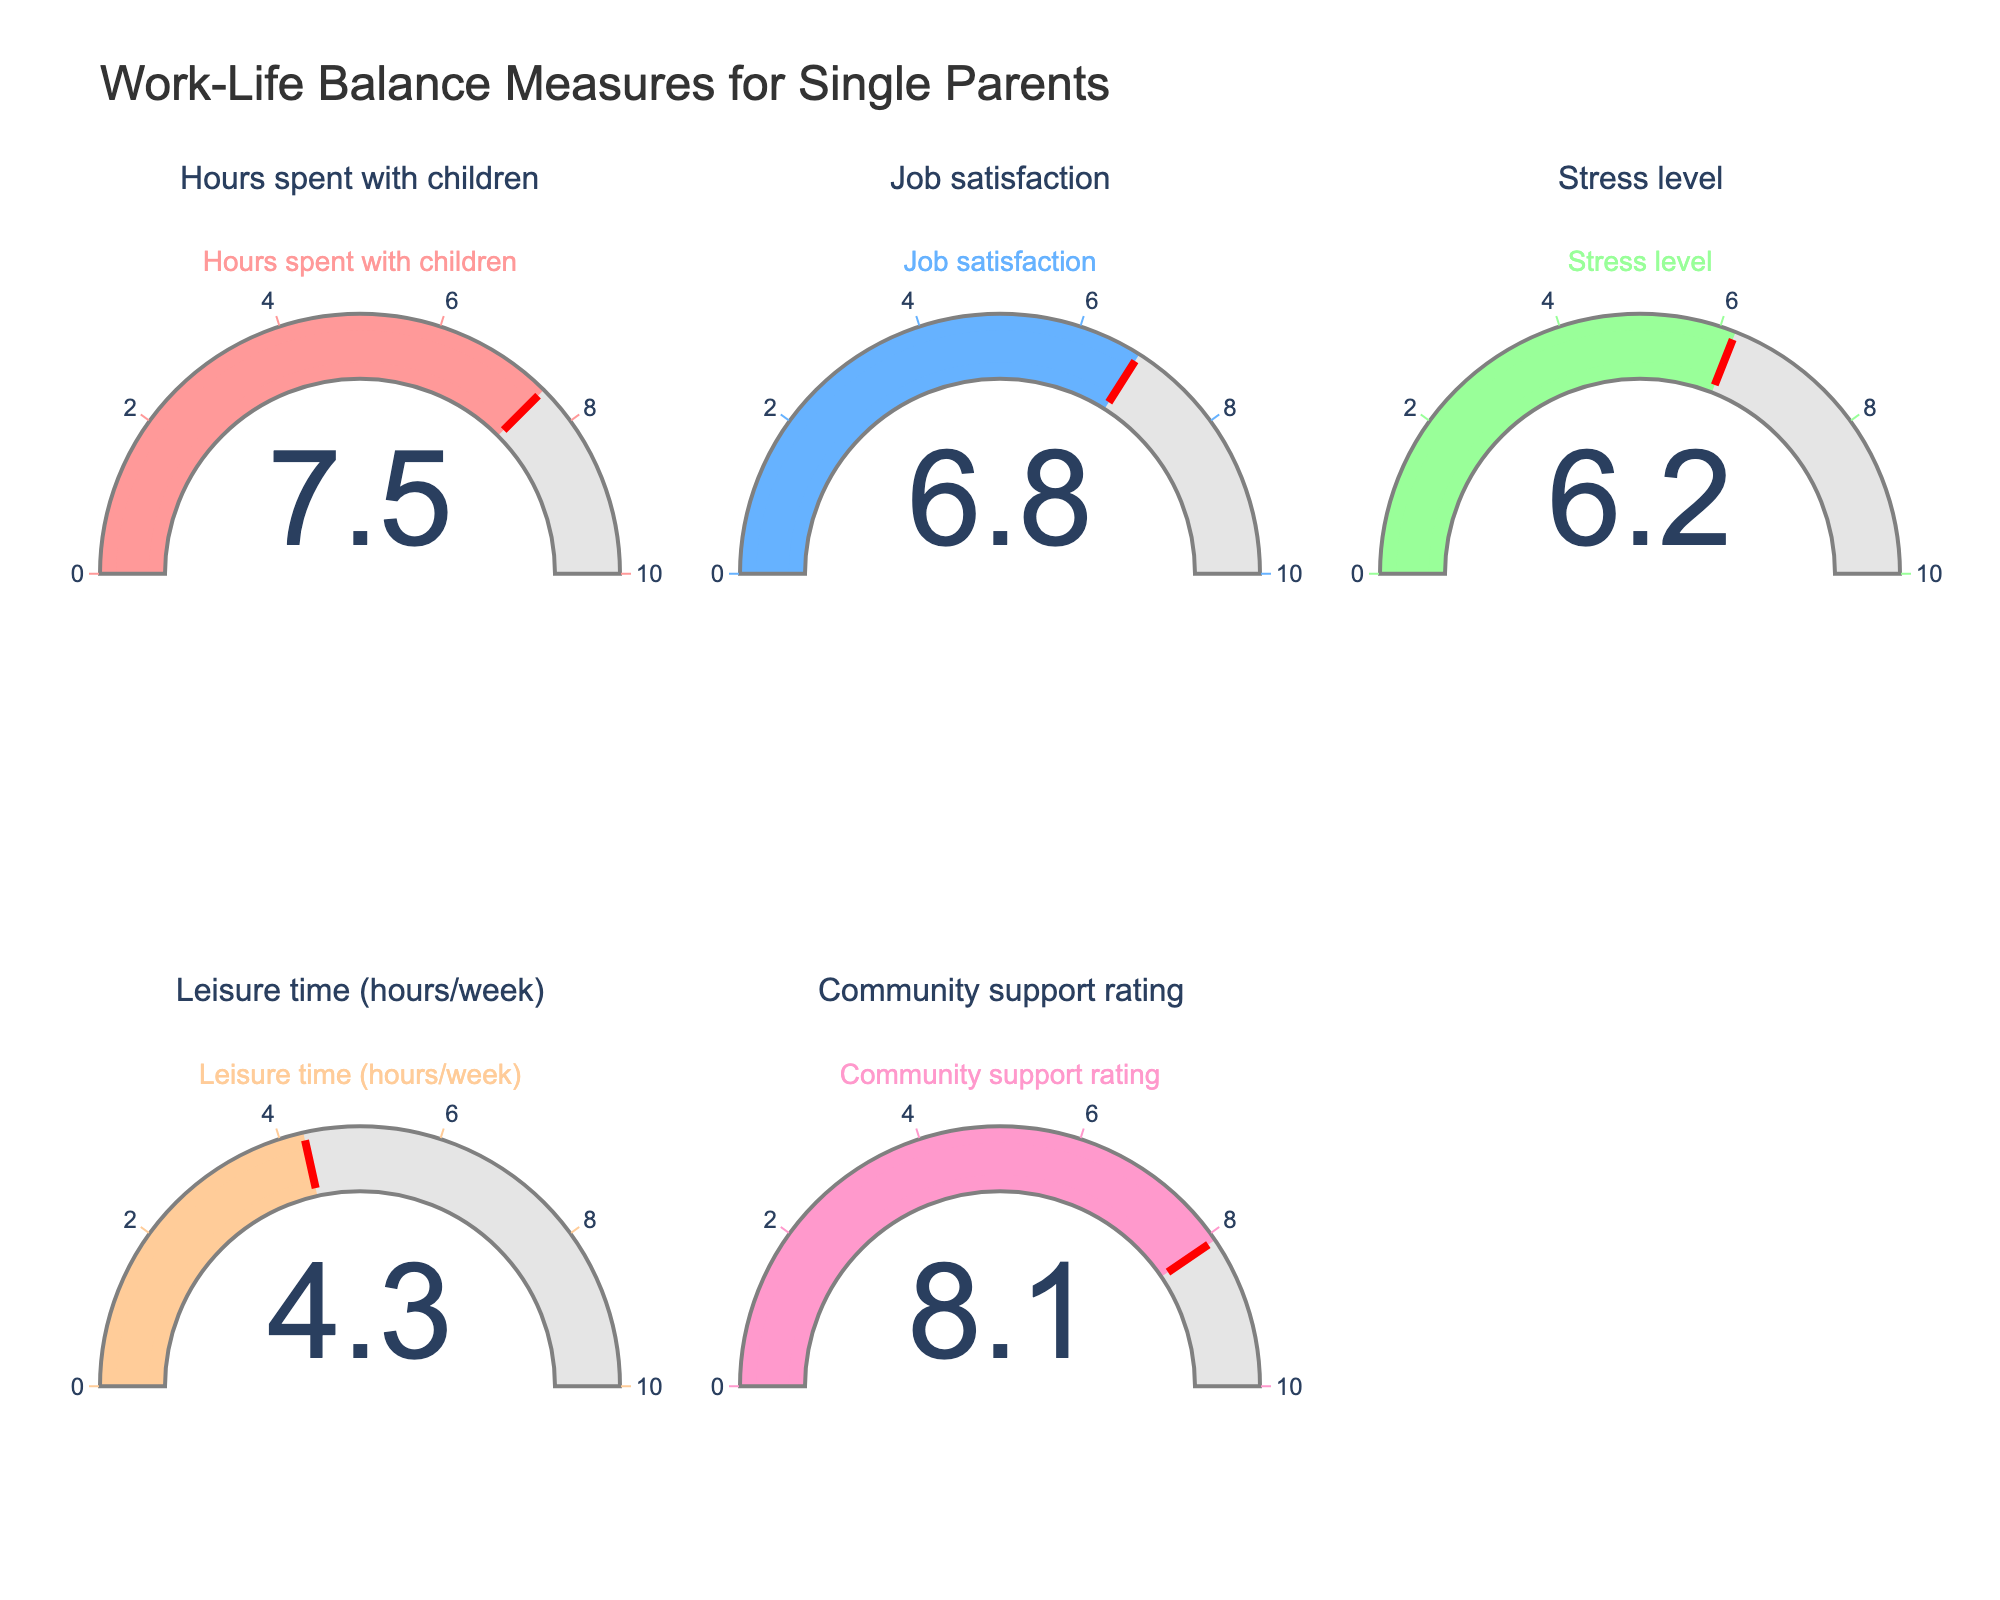what is the highest value on the gauge chart? The Community support rating gauge shows the highest value of 8.1 among all the gauges listed in the chart.
Answer: 8.1 Which measure has the lowest value? By inspecting all the gauges, the Leisure time (hours/week) measure has the lowest value at 4.3.
Answer: Leisure time (hours/week) How does the Job satisfaction gauge value compare to the Stress level gauge value? The Job satisfaction gauge has a value of 6.8, and the Stress level gauge has a value of 6.2. Job satisfaction is slightly higher than the Stress level.
Answer: Job satisfaction is higher What is the average value of all the measures? Adding all the values: 7.5 (Hours spent with children) + 6.8 (Job satisfaction) + 6.2 (Stress level) + 4.3 (Leisure time) + 8.1 (Community support rating) = 32.9. Dividing by the number of measures (5): 32.9 / 5 = 6.58.
Answer: 6.58 Is the Stress level value closer to the highest or lowest value on the chart? The highest value is 8.1 (Community support rating) and the lowest value is 4.3 (Leisure time). Stress level is 6.2, which is closer to the highest value (8.1 - 6.2 = 1.9) compared to the lowest (6.2 - 4.3 = 1.9).
Answer: Closer to the highest value What is the difference between the values for Hours spent with children and Leisure time (hours/week)? The value for Hours spent with children is 7.5, and Leisure time is 4.3. The difference is 7.5 - 4.3 = 3.2.
Answer: 3.2 Which gauges need more effort to balance based on their current values? Higher stress levels and lower leisure time suggest areas that need more effort. Stress Level (6.2) and Leisure time (4.3) indicate imbalance areas.
Answer: Stress Level and Leisure time Which measure is closest to the average value of all the measures? The average value of all measures is 6.58. Comparing individual values, Job satisfaction is 6.8, which is closest to 6.58.
Answer: Job satisfaction 